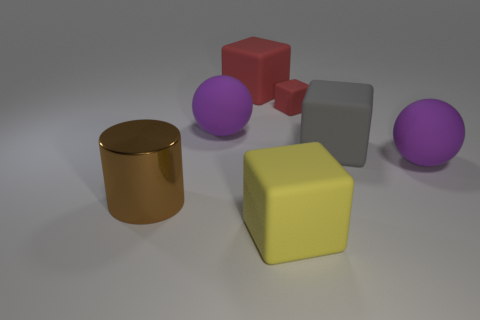Are there any other things that are made of the same material as the large brown thing?
Provide a succinct answer. No. Does the big matte block on the left side of the yellow thing have the same color as the tiny object?
Give a very brief answer. Yes. Are there any things of the same color as the small block?
Provide a succinct answer. Yes. There is a rubber ball that is on the left side of the yellow block; is its color the same as the rubber sphere right of the yellow rubber thing?
Make the answer very short. Yes. What size is the other matte object that is the same color as the tiny object?
Your answer should be very brief. Large. How many cubes are either big gray matte objects or large red rubber things?
Make the answer very short. 2. Does the big red thing have the same material as the small red block?
Your answer should be compact. Yes. What number of other objects are the same color as the large cylinder?
Your answer should be very brief. 0. What shape is the matte thing that is in front of the cylinder?
Offer a very short reply. Cube. How many things are either brown metal objects or big blue blocks?
Your answer should be very brief. 1. 